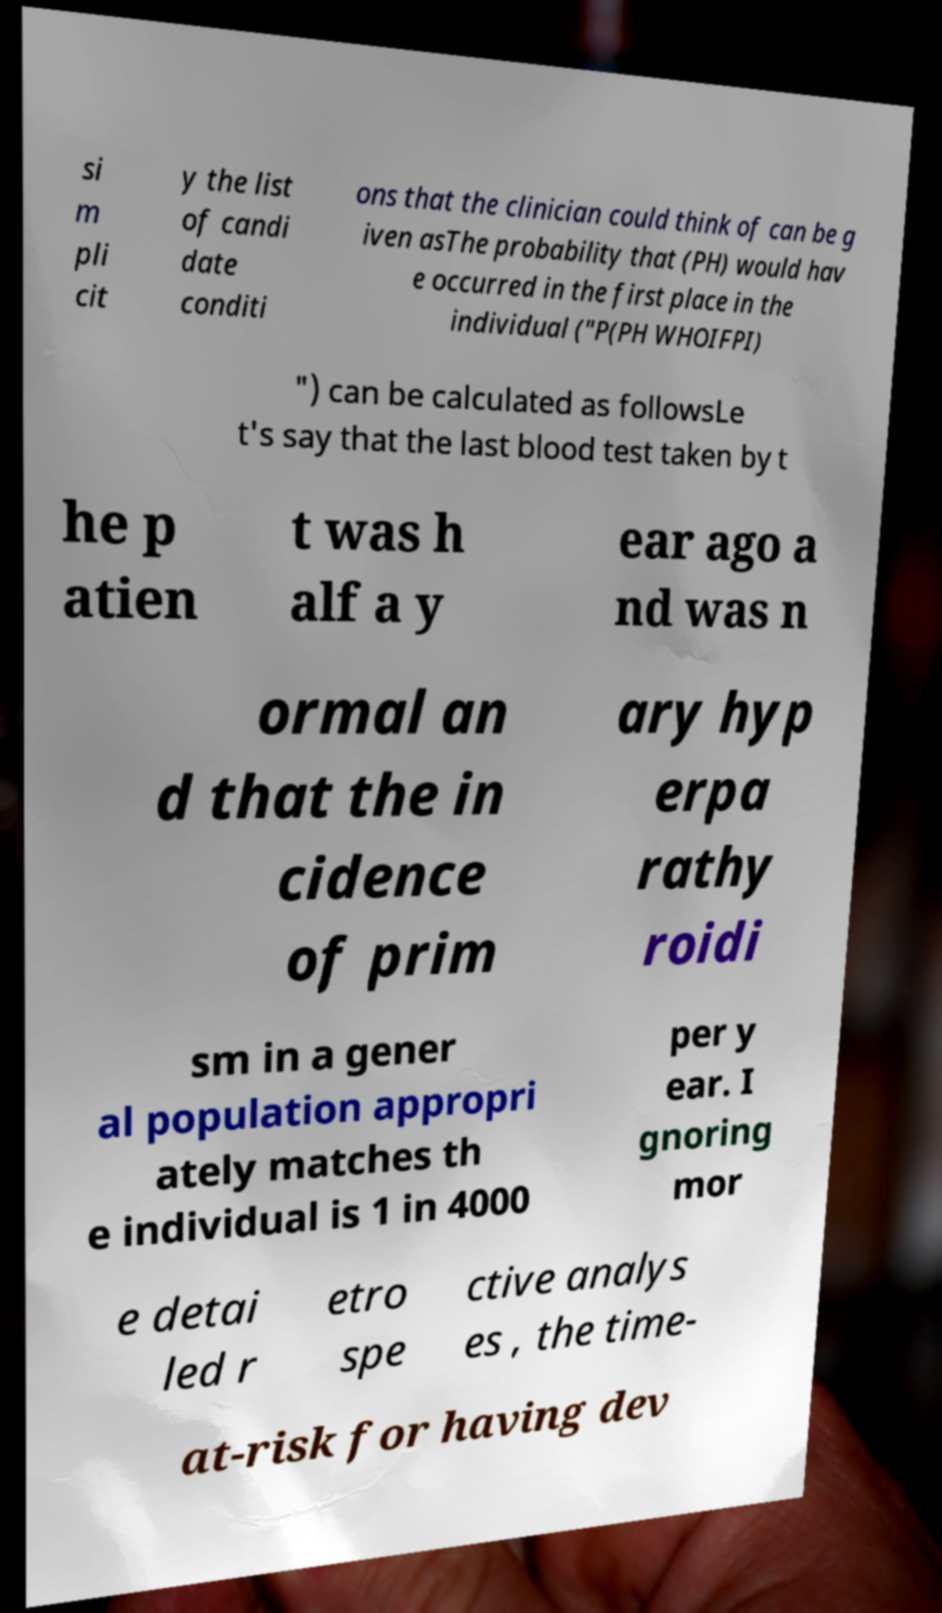There's text embedded in this image that I need extracted. Can you transcribe it verbatim? si m pli cit y the list of candi date conditi ons that the clinician could think of can be g iven asThe probability that (PH) would hav e occurred in the first place in the individual ("P(PH WHOIFPI) ") can be calculated as followsLe t's say that the last blood test taken by t he p atien t was h alf a y ear ago a nd was n ormal an d that the in cidence of prim ary hyp erpa rathy roidi sm in a gener al population appropri ately matches th e individual is 1 in 4000 per y ear. I gnoring mor e detai led r etro spe ctive analys es , the time- at-risk for having dev 